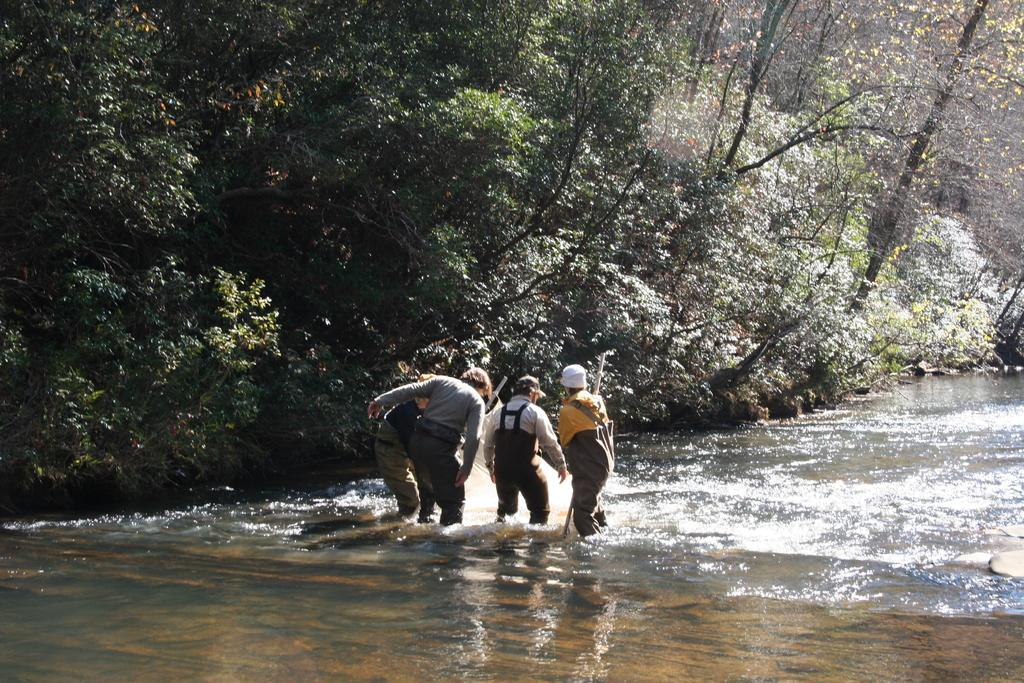Who or what is present in the image? There are people in the image. What natural element can be seen in the image? There is water visible in the image. What type of vegetation is present in the image? There are trees in the image. What type of skin condition can be seen on the people in the image? There is no indication of any skin condition on the people in the image. What type of art is displayed in the image? There is no art present in the image; it features people, water, and trees. 